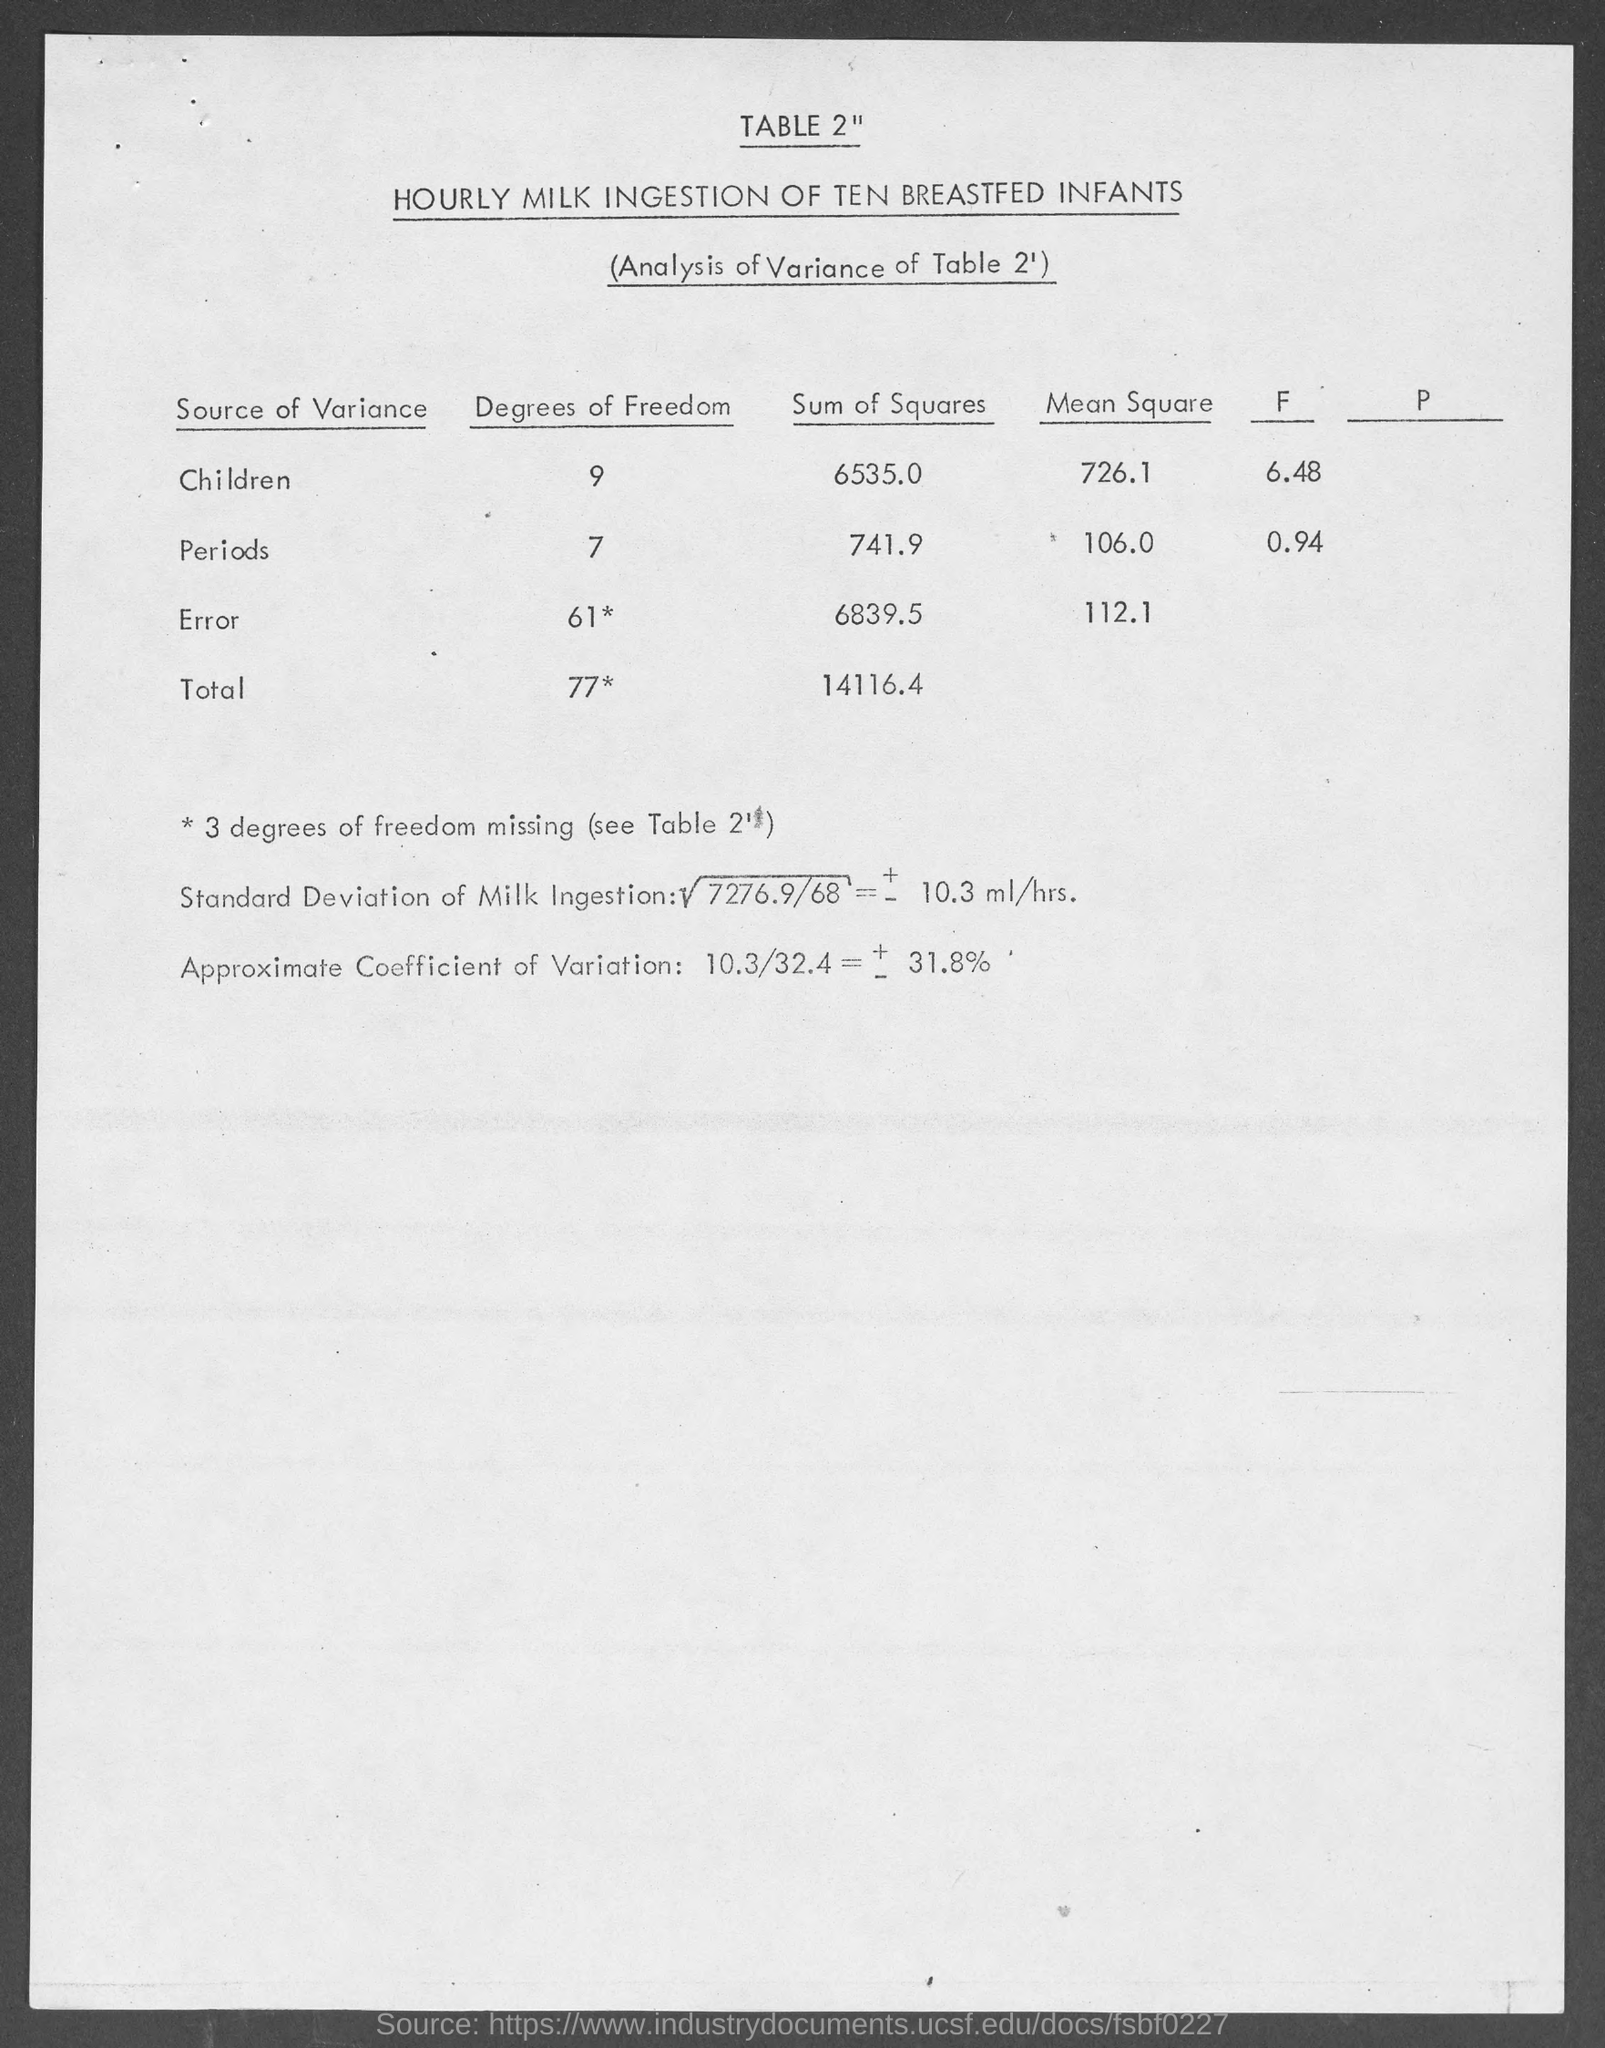Indicate a few pertinent items in this graphic. The sum of squares for children is 6535. The mean square for children is 726.1. The degrees of freedom for children is 9. The total degrees of freedom is 77. The title of Table 2 is "Hourly Milk Ingestion of Ten Breastfed Infants. 